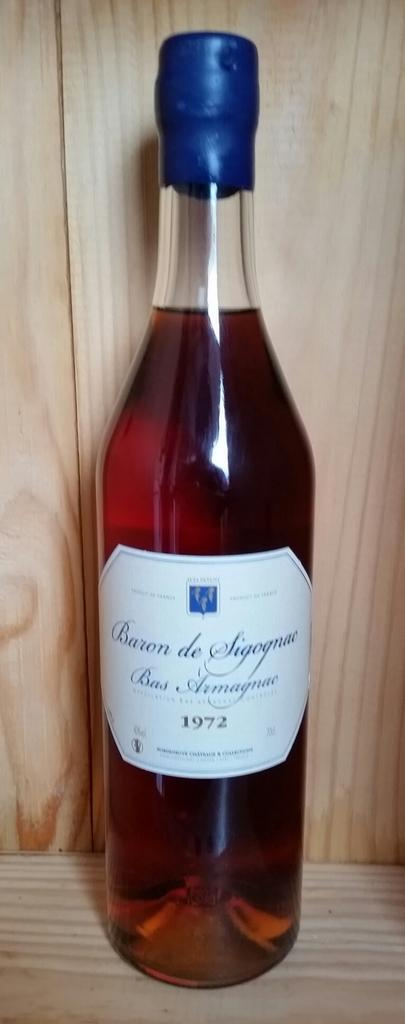<image>
Give a short and clear explanation of the subsequent image. A great bottle of Armagnac with a blue top from vintage 1972. 